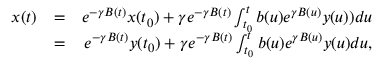<formula> <loc_0><loc_0><loc_500><loc_500>\begin{array} { r l r } { x ( t ) } & { = } & { e ^ { - \gamma B ( t ) } x ( t _ { 0 } ) + \gamma e ^ { - \gamma B ( t ) } \int _ { t _ { 0 } } ^ { t } b ( u ) e ^ { \gamma B ( u ) } y ( u ) ) d u } \\ & { = } & { e ^ { - \gamma B ( t ) } y ( t _ { 0 } ) + \gamma e ^ { - \gamma B ( t ) } \int _ { t _ { 0 } } ^ { t } b ( u ) e ^ { \gamma B ( u ) } y ( u ) d u , } \end{array}</formula> 